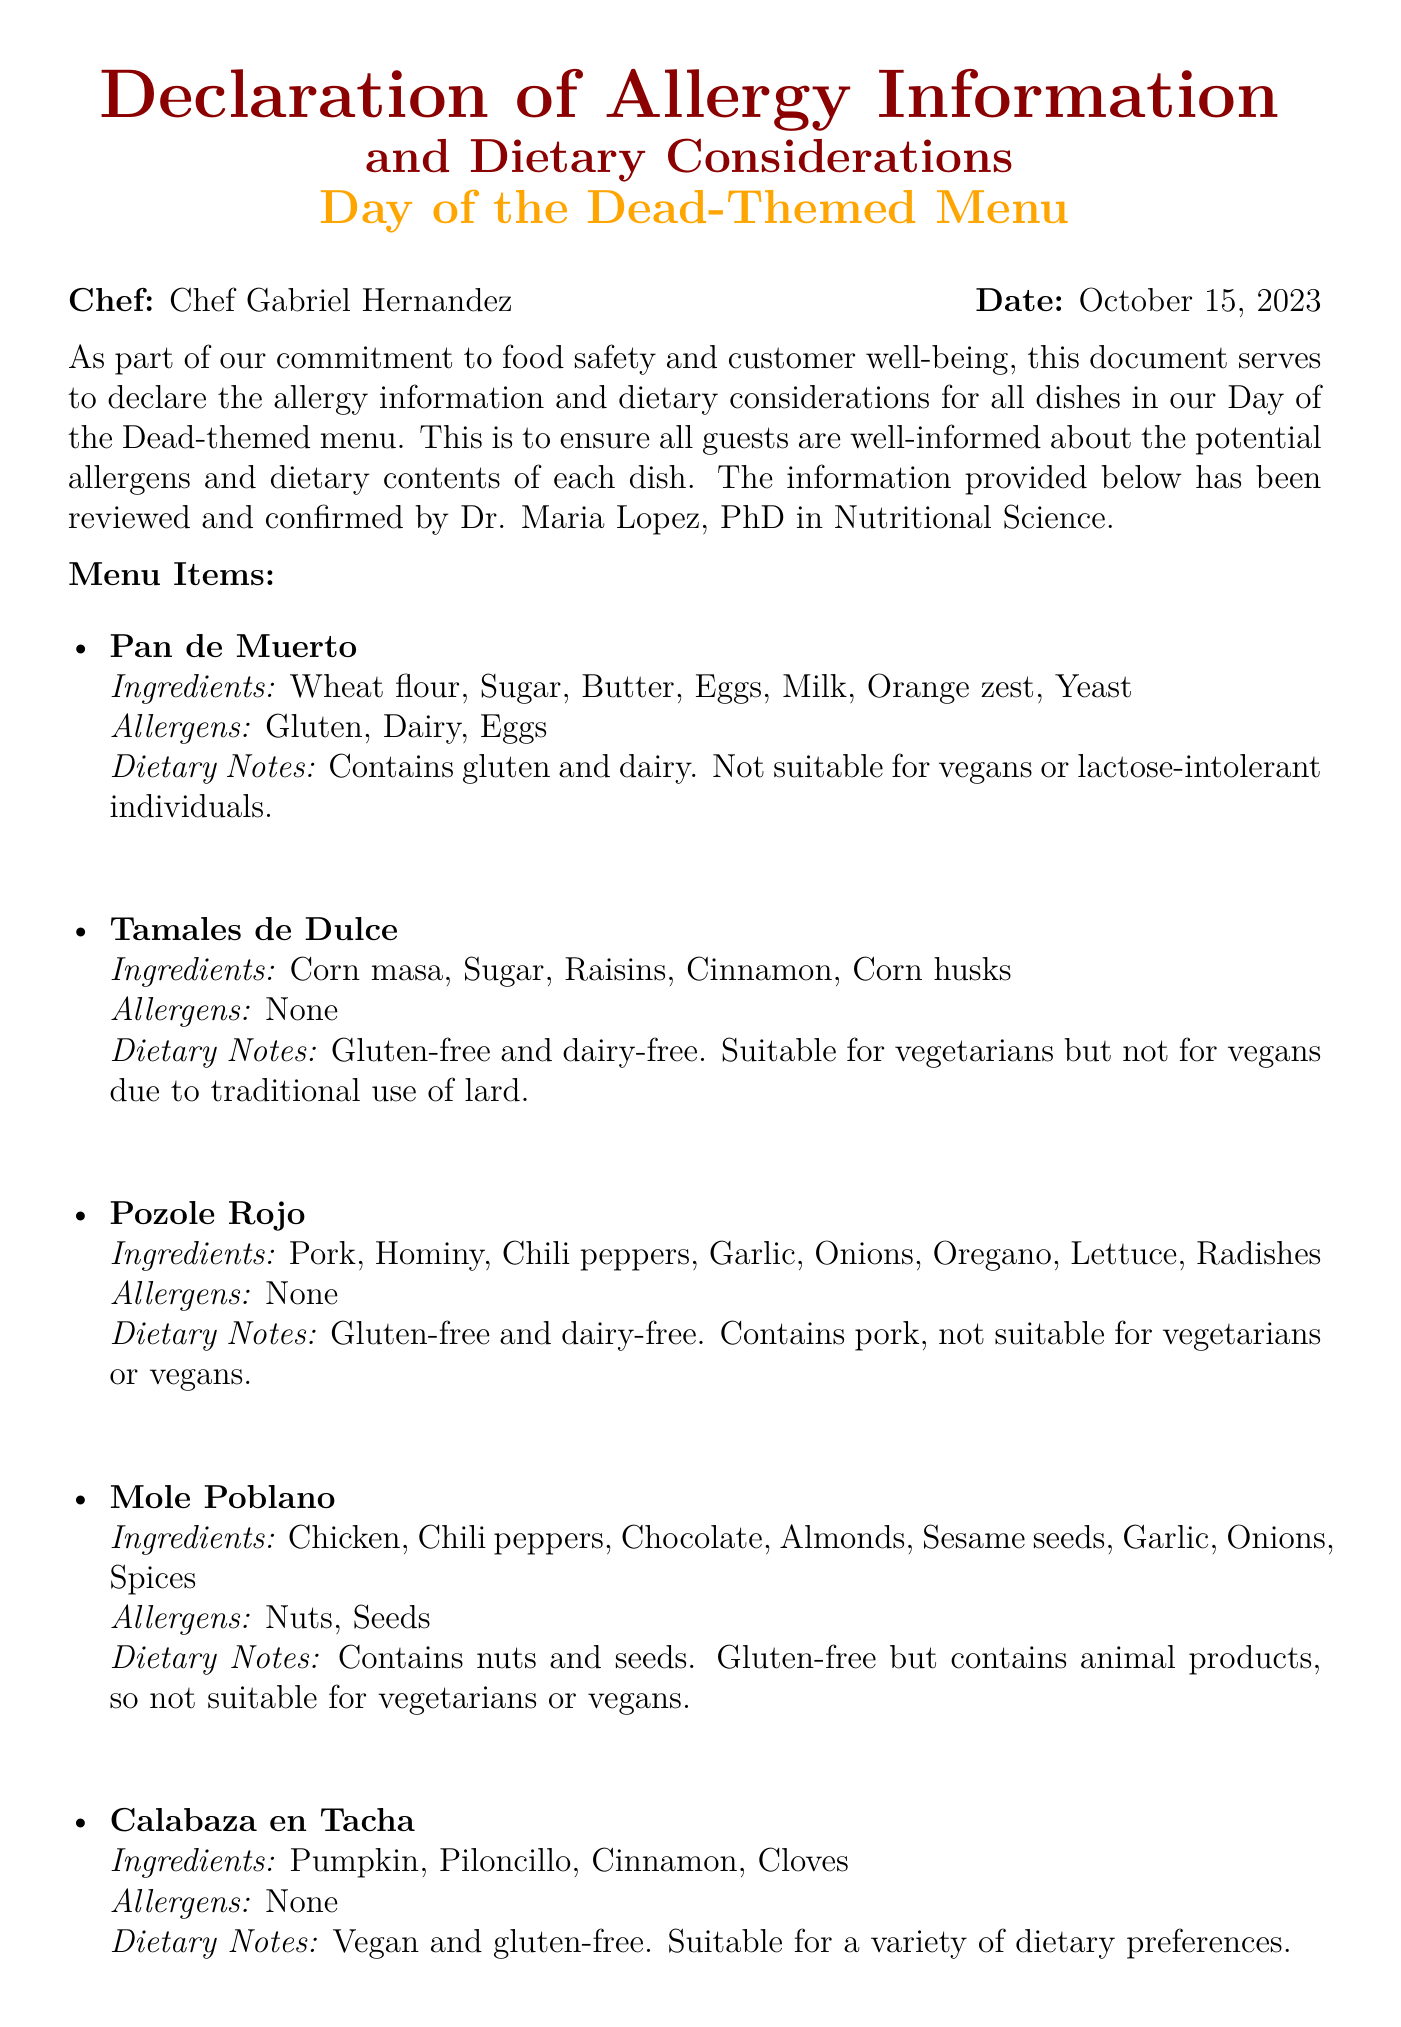What is the chef's name? The chef's name is stated at the beginning of the document.
Answer: Chef Gabriel Hernandez What is the date of the declaration? The date is indicated in the document next to the chef's name.
Answer: October 15, 2023 Who reviewed and confirmed the information? The document mentions the person who reviewed it before being signed.
Answer: Dr. Maria Lopez How many dishes are listed in the menu? The number of dishes can be counted in the menu items section.
Answer: Five Which dish contains gluten? The dish that contains gluten is specifically mentioned in the allergen section for certain dishes.
Answer: Pan de Muerto Which dish is vegan and gluten-free? The dish that is explicitly labeled as vegan and gluten-free may be identified in the dietary notes section.
Answer: Calabaza en Tacha What is the main allergen for Mole Poblano? The main allergens related to this dish are specified in the allergen section.
Answer: Nuts, Seeds Is Pozole Rojo suitable for vegetarians? The dietary notes section for this dish clarifies its suitability for certain diets.
Answer: No What dietary consideration is mentioned for Tamales de Dulce? The dietary notes for this dish describe notable dietary considerations.
Answer: Vegetarian 